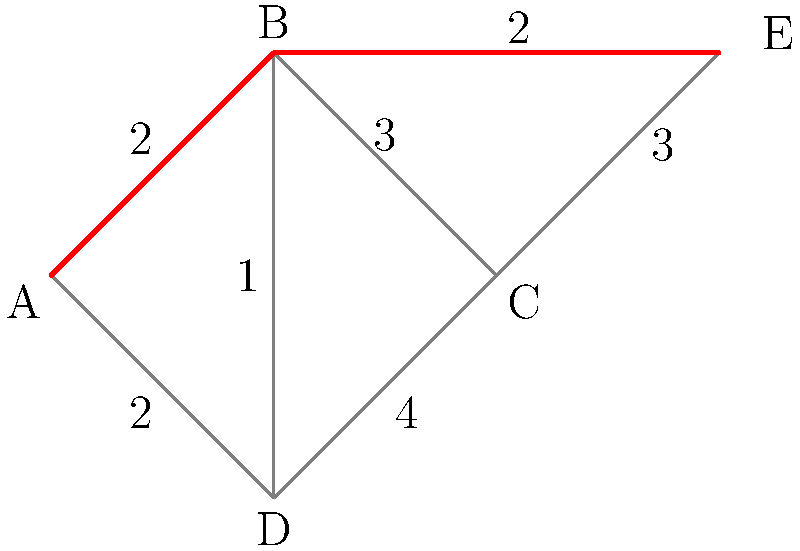In the context of conflict resolution, the graph represents different stakeholders (nodes) and potential negotiation channels (edges) in a complex geopolitical landscape. The weights on the edges indicate the difficulty level of establishing dialogue. What is the shortest path from node A (representing grassroots peace initiatives) to node E (representing international mediation efforts), and what does this path signify for non-violent conflict resolution? To find the shortest path from A to E, we need to consider all possible routes and their total weights:

1. A → B → E: Weight = 2 + 2 = 4
2. A → B → C → E: Weight = 2 + 3 + 3 = 8
3. A → D → B → E: Weight = 2 + 1 + 2 = 5
4. A → D → C → E: Weight = 2 + 4 + 3 = 9

The shortest path is A → B → E with a total weight of 4.

This path signifies:

1. Grassroots initiatives (A) should first engage with local authorities or community leaders (B).
2. These local actors (B) then connect directly with international mediation efforts (E).

The shorter path suggests:

1. Efficiency: Fewer intermediaries reduce potential miscommunication.
2. Direct engagement: Grassroots voices reach international mediators more quickly.
3. Reduced complexity: Fewer steps mean less potential for conflict escalation.
4. Empowerment: Local initiatives gain direct access to international support.

This non-violent approach emphasizes the importance of local involvement and international cooperation in conflict resolution, aligning with the peace advocate's perspective.
Answer: A → B → E; empowers local initiatives, streamlines communication with international mediators 